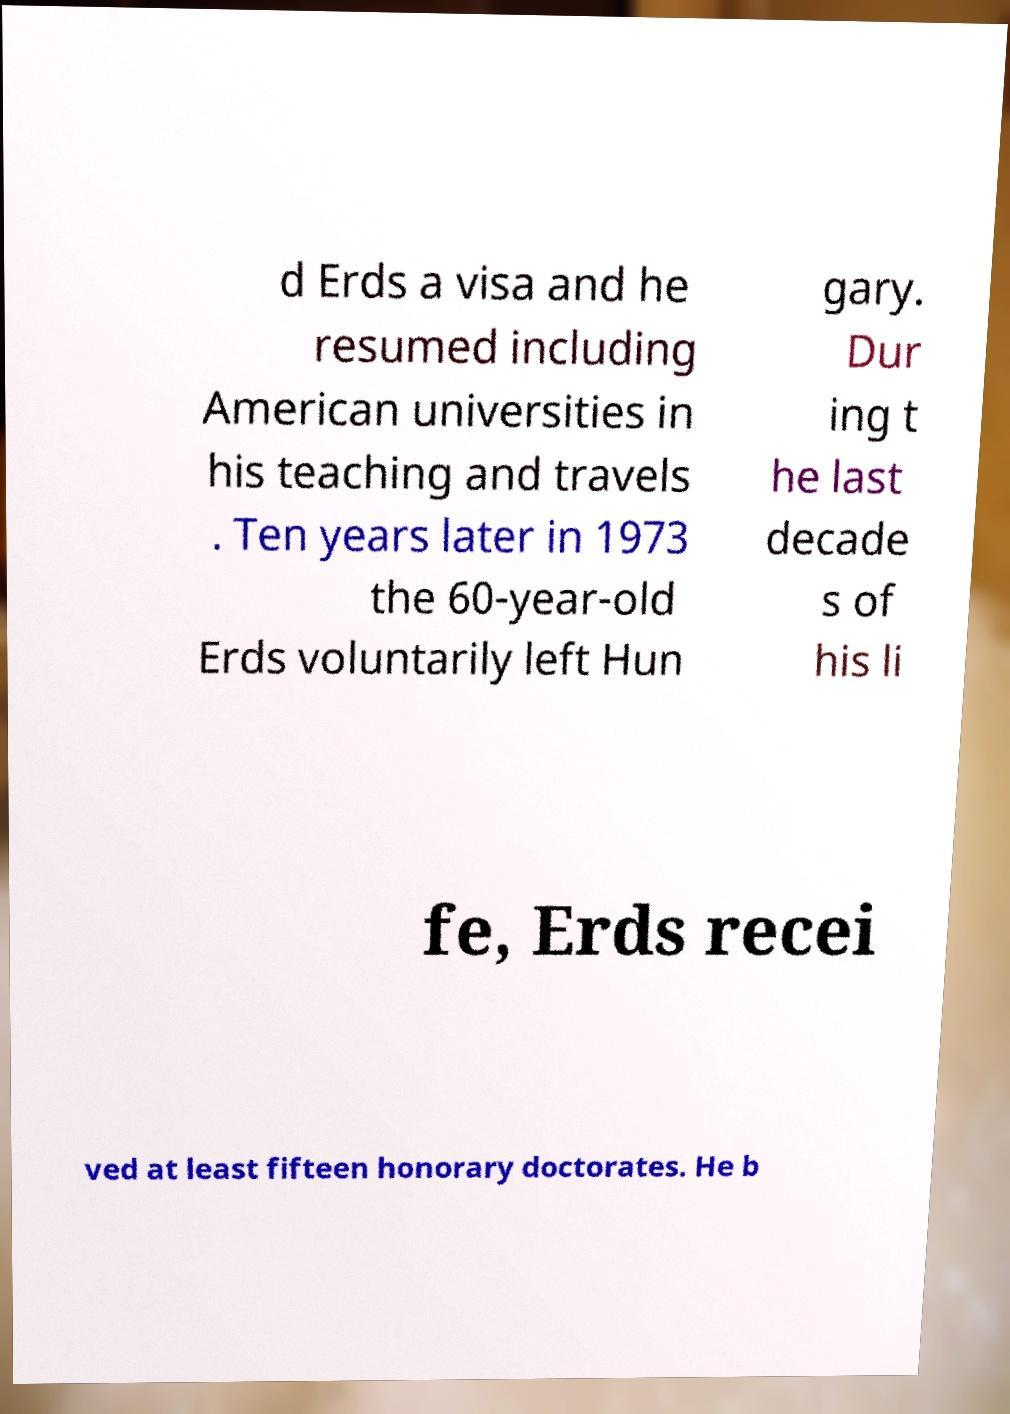Could you assist in decoding the text presented in this image and type it out clearly? d Erds a visa and he resumed including American universities in his teaching and travels . Ten years later in 1973 the 60-year-old Erds voluntarily left Hun gary. Dur ing t he last decade s of his li fe, Erds recei ved at least fifteen honorary doctorates. He b 